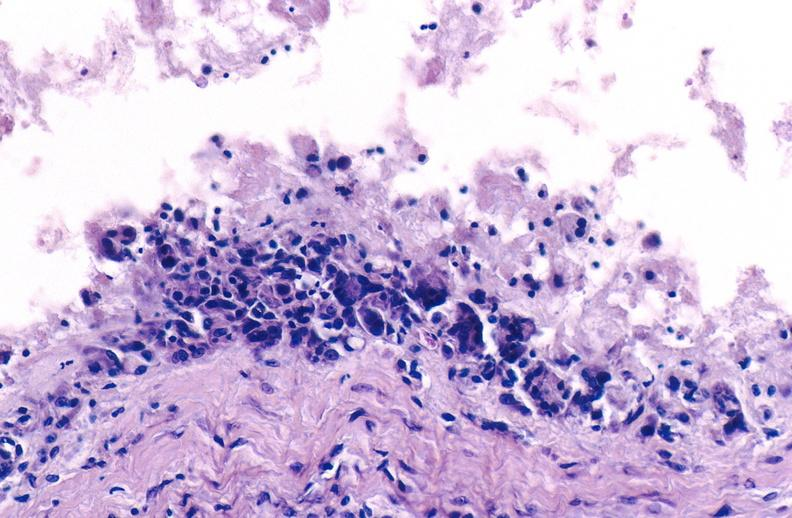what is present?
Answer the question using a single word or phrase. Joints 